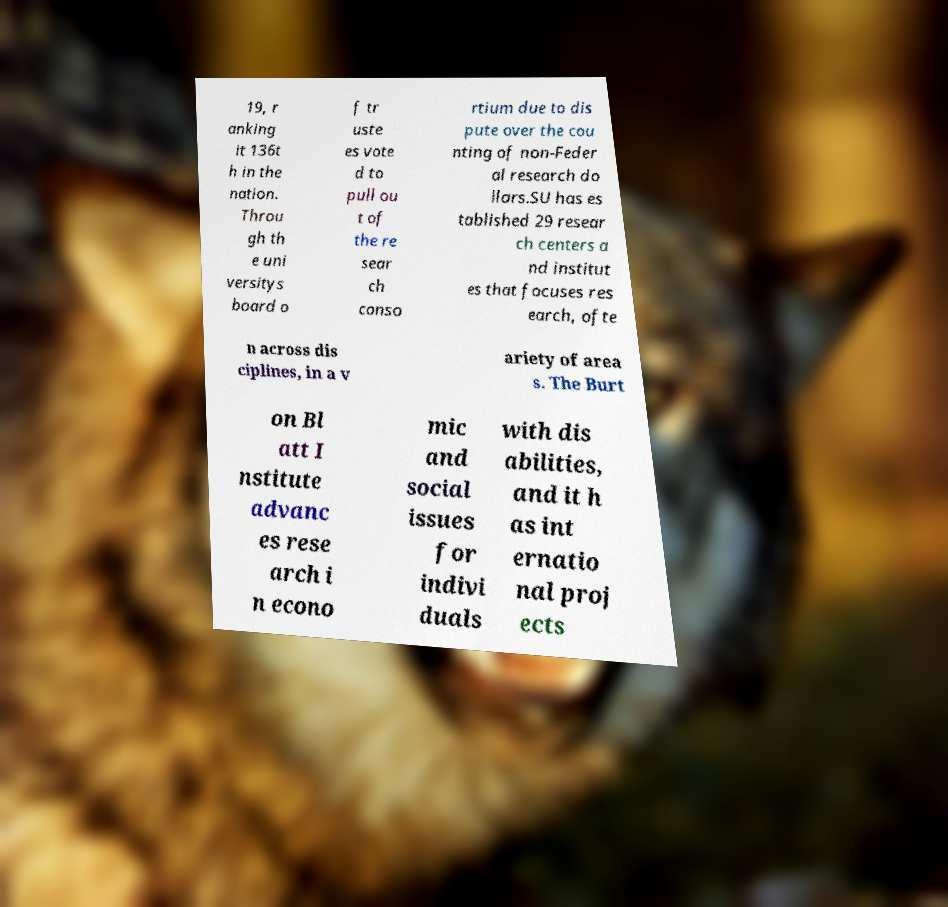I need the written content from this picture converted into text. Can you do that? 19, r anking it 136t h in the nation. Throu gh th e uni versitys board o f tr uste es vote d to pull ou t of the re sear ch conso rtium due to dis pute over the cou nting of non-Feder al research do llars.SU has es tablished 29 resear ch centers a nd institut es that focuses res earch, ofte n across dis ciplines, in a v ariety of area s. The Burt on Bl att I nstitute advanc es rese arch i n econo mic and social issues for indivi duals with dis abilities, and it h as int ernatio nal proj ects 